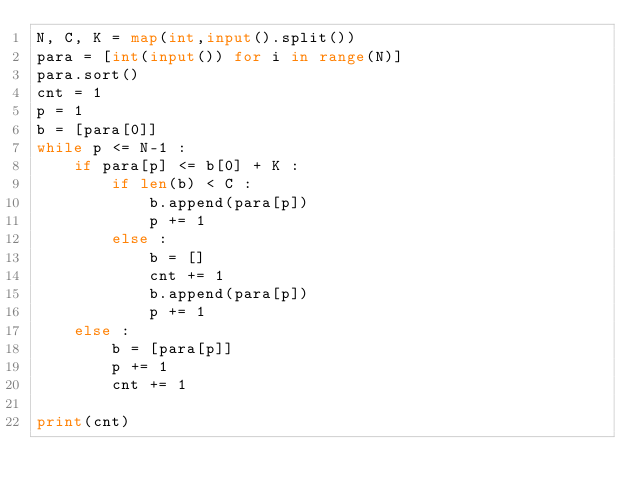Convert code to text. <code><loc_0><loc_0><loc_500><loc_500><_Python_>N, C, K = map(int,input().split())
para = [int(input()) for i in range(N)]
para.sort()
cnt = 1
p = 1
b = [para[0]]
while p <= N-1 :  
    if para[p] <= b[0] + K :
        if len(b) < C :
            b.append(para[p])
            p += 1 
        else :
            b = []
            cnt += 1 
            b.append(para[p])
            p += 1  
    else :
        b = [para[p]]
        p += 1
        cnt += 1

print(cnt)</code> 